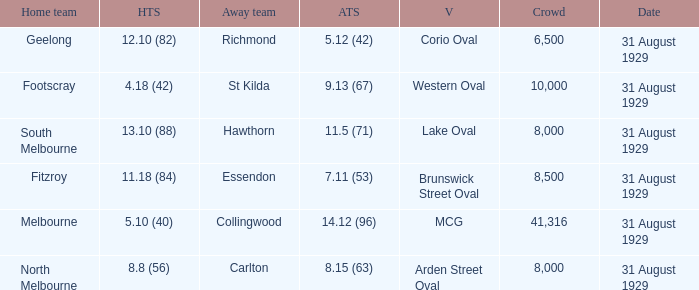Can you give me this table as a dict? {'header': ['Home team', 'HTS', 'Away team', 'ATS', 'V', 'Crowd', 'Date'], 'rows': [['Geelong', '12.10 (82)', 'Richmond', '5.12 (42)', 'Corio Oval', '6,500', '31 August 1929'], ['Footscray', '4.18 (42)', 'St Kilda', '9.13 (67)', 'Western Oval', '10,000', '31 August 1929'], ['South Melbourne', '13.10 (88)', 'Hawthorn', '11.5 (71)', 'Lake Oval', '8,000', '31 August 1929'], ['Fitzroy', '11.18 (84)', 'Essendon', '7.11 (53)', 'Brunswick Street Oval', '8,500', '31 August 1929'], ['Melbourne', '5.10 (40)', 'Collingwood', '14.12 (96)', 'MCG', '41,316', '31 August 1929'], ['North Melbourne', '8.8 (56)', 'Carlton', '8.15 (63)', 'Arden Street Oval', '8,000', '31 August 1929']]} What is the largest crowd when the away team is Hawthorn? 8000.0. 